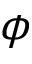<formula> <loc_0><loc_0><loc_500><loc_500>\phi</formula> 